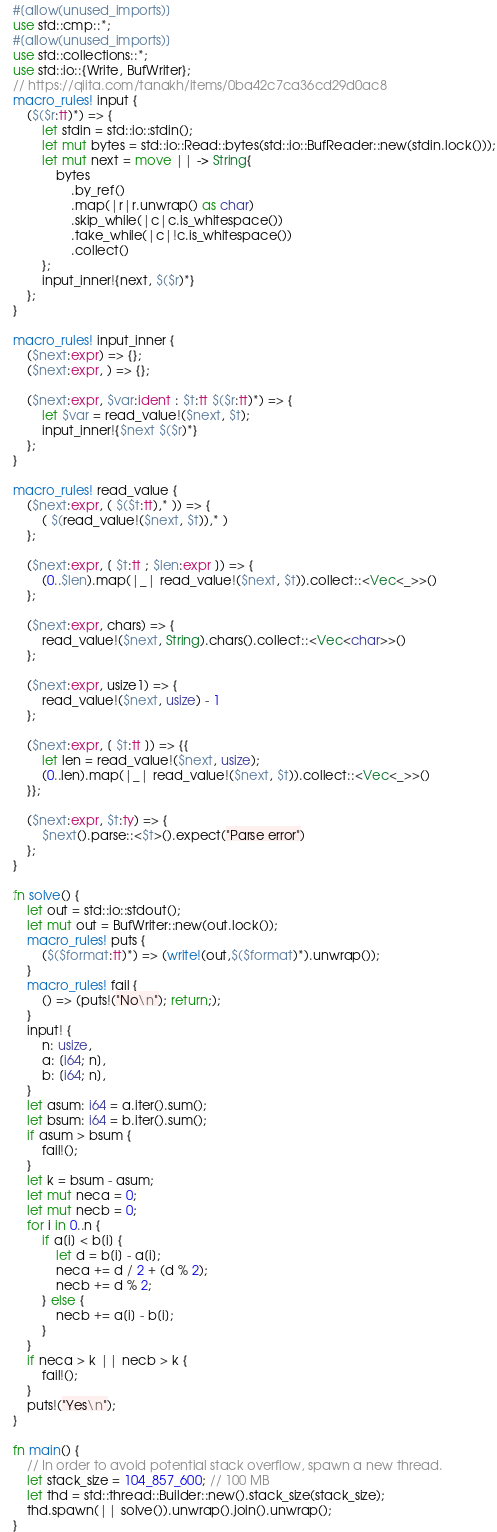<code> <loc_0><loc_0><loc_500><loc_500><_Rust_>#[allow(unused_imports)]
use std::cmp::*;
#[allow(unused_imports)]
use std::collections::*;
use std::io::{Write, BufWriter};
// https://qiita.com/tanakh/items/0ba42c7ca36cd29d0ac8
macro_rules! input {
    ($($r:tt)*) => {
        let stdin = std::io::stdin();
        let mut bytes = std::io::Read::bytes(std::io::BufReader::new(stdin.lock()));
        let mut next = move || -> String{
            bytes
                .by_ref()
                .map(|r|r.unwrap() as char)
                .skip_while(|c|c.is_whitespace())
                .take_while(|c|!c.is_whitespace())
                .collect()
        };
        input_inner!{next, $($r)*}
    };
}

macro_rules! input_inner {
    ($next:expr) => {};
    ($next:expr, ) => {};

    ($next:expr, $var:ident : $t:tt $($r:tt)*) => {
        let $var = read_value!($next, $t);
        input_inner!{$next $($r)*}
    };
}

macro_rules! read_value {
    ($next:expr, ( $($t:tt),* )) => {
        ( $(read_value!($next, $t)),* )
    };

    ($next:expr, [ $t:tt ; $len:expr ]) => {
        (0..$len).map(|_| read_value!($next, $t)).collect::<Vec<_>>()
    };

    ($next:expr, chars) => {
        read_value!($next, String).chars().collect::<Vec<char>>()
    };

    ($next:expr, usize1) => {
        read_value!($next, usize) - 1
    };

    ($next:expr, [ $t:tt ]) => {{
        let len = read_value!($next, usize);
        (0..len).map(|_| read_value!($next, $t)).collect::<Vec<_>>()
    }};

    ($next:expr, $t:ty) => {
        $next().parse::<$t>().expect("Parse error")
    };
}

fn solve() {
    let out = std::io::stdout();
    let mut out = BufWriter::new(out.lock());
    macro_rules! puts {
        ($($format:tt)*) => (write!(out,$($format)*).unwrap());
    }
    macro_rules! fail {
        () => (puts!("No\n"); return;);
    }
    input! {
        n: usize,
        a: [i64; n],
        b: [i64; n],
    }
    let asum: i64 = a.iter().sum();
    let bsum: i64 = b.iter().sum();
    if asum > bsum {
        fail!();
    }
    let k = bsum - asum;
    let mut neca = 0;
    let mut necb = 0;
    for i in 0..n {
        if a[i] < b[i] {
            let d = b[i] - a[i];
            neca += d / 2 + (d % 2);
            necb += d % 2;
        } else {
            necb += a[i] - b[i];
        }
    }
    if neca > k || necb > k {
        fail!();
    }
    puts!("Yes\n");
}

fn main() {
    // In order to avoid potential stack overflow, spawn a new thread.
    let stack_size = 104_857_600; // 100 MB
    let thd = std::thread::Builder::new().stack_size(stack_size);
    thd.spawn(|| solve()).unwrap().join().unwrap();
}
</code> 